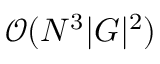Convert formula to latex. <formula><loc_0><loc_0><loc_500><loc_500>\mathcal { O } ( N ^ { 3 } | G | ^ { 2 } )</formula> 